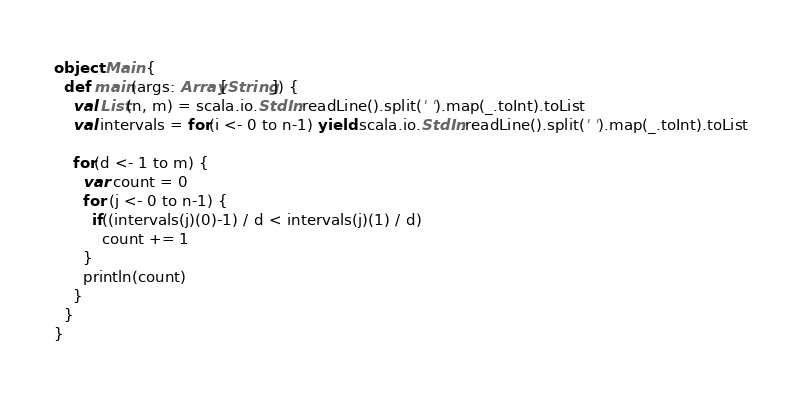Convert code to text. <code><loc_0><loc_0><loc_500><loc_500><_Scala_>object Main {
  def main(args: Array[String]) {
    val List(n, m) = scala.io.StdIn.readLine().split(' ').map(_.toInt).toList
    val intervals = for(i <- 0 to n-1) yield scala.io.StdIn.readLine().split(' ').map(_.toInt).toList
    
    for(d <- 1 to m) {
      var count = 0
      for (j <- 0 to n-1) {
        if((intervals(j)(0)-1) / d < intervals(j)(1) / d)
          count += 1
      }
      println(count)
    }
  }
}
</code> 